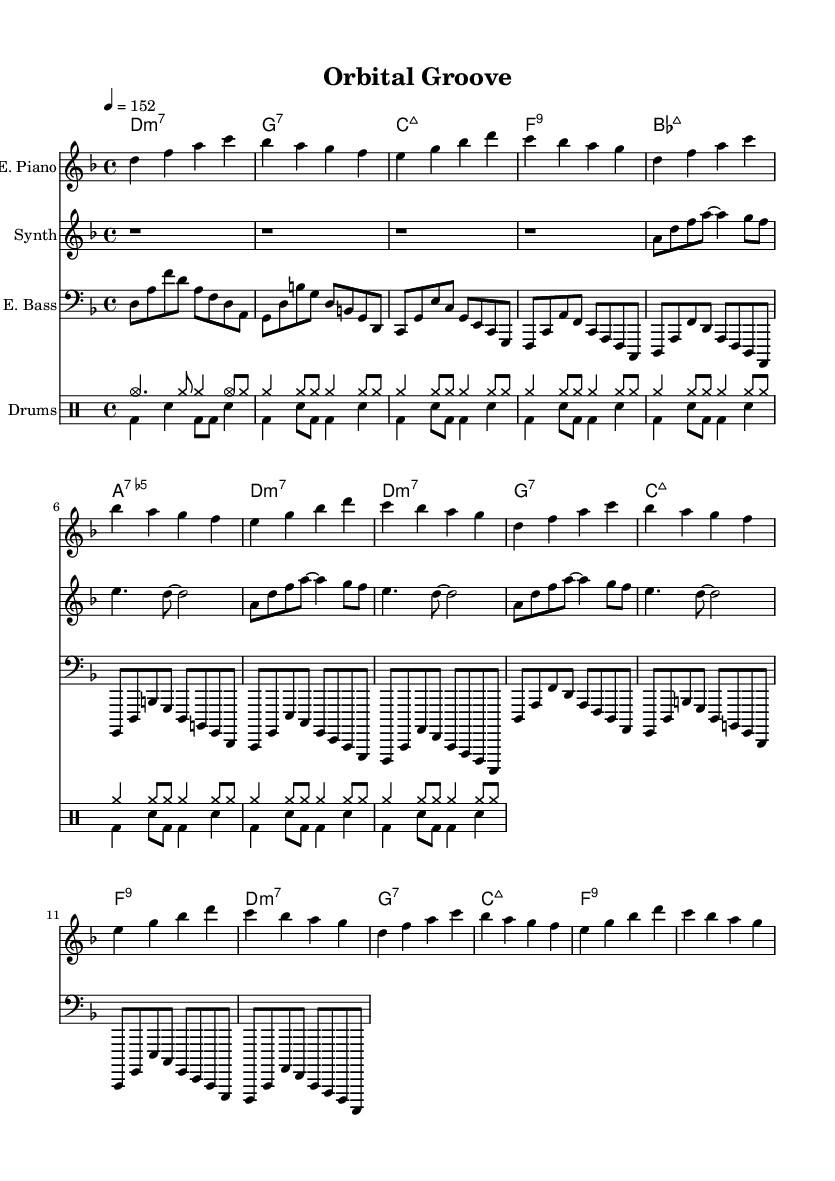What is the key signature of this music? The key signature is indicated at the beginning of the staff, displaying two flats, which means it is in the key of D minor.
Answer: D minor What is the time signature of the piece? The time signature is depicted at the beginning and shows four beats per measure, indicated by "4/4".
Answer: 4/4 What is the tempo marking for this piece? The tempo is marked at the beginning, stating "4 = 152", which means the quarter note is to be played at 152 beats per minute.
Answer: 152 How many measures are in the electric piano part? By examining the electric piano notation, we can count the measures, which shows it repeats a sequence 3 times following the first pass, totaling 12 measures.
Answer: 12 Which instrument plays the synthesizer part? The synthesizer part is labeled as "Synth" in front of the staff on the sheet music, indicating that this is the designated instrument for that line.
Answer: Synth What type of chords are predominantly used in this piece? Looking at the chord names indicated above the staff, we see that seventh chords are frequently employed, specifically minor and dominant seventh chords.
Answer: Seventh chords How is the drum pattern structured in relation to the measures? The drum patterns are structured in repeated sequences, evident in both the "drumsUp" and "drumsDown" sections, where they have consistent rhythmic patterns throughout.
Answer: Repeated sequences 